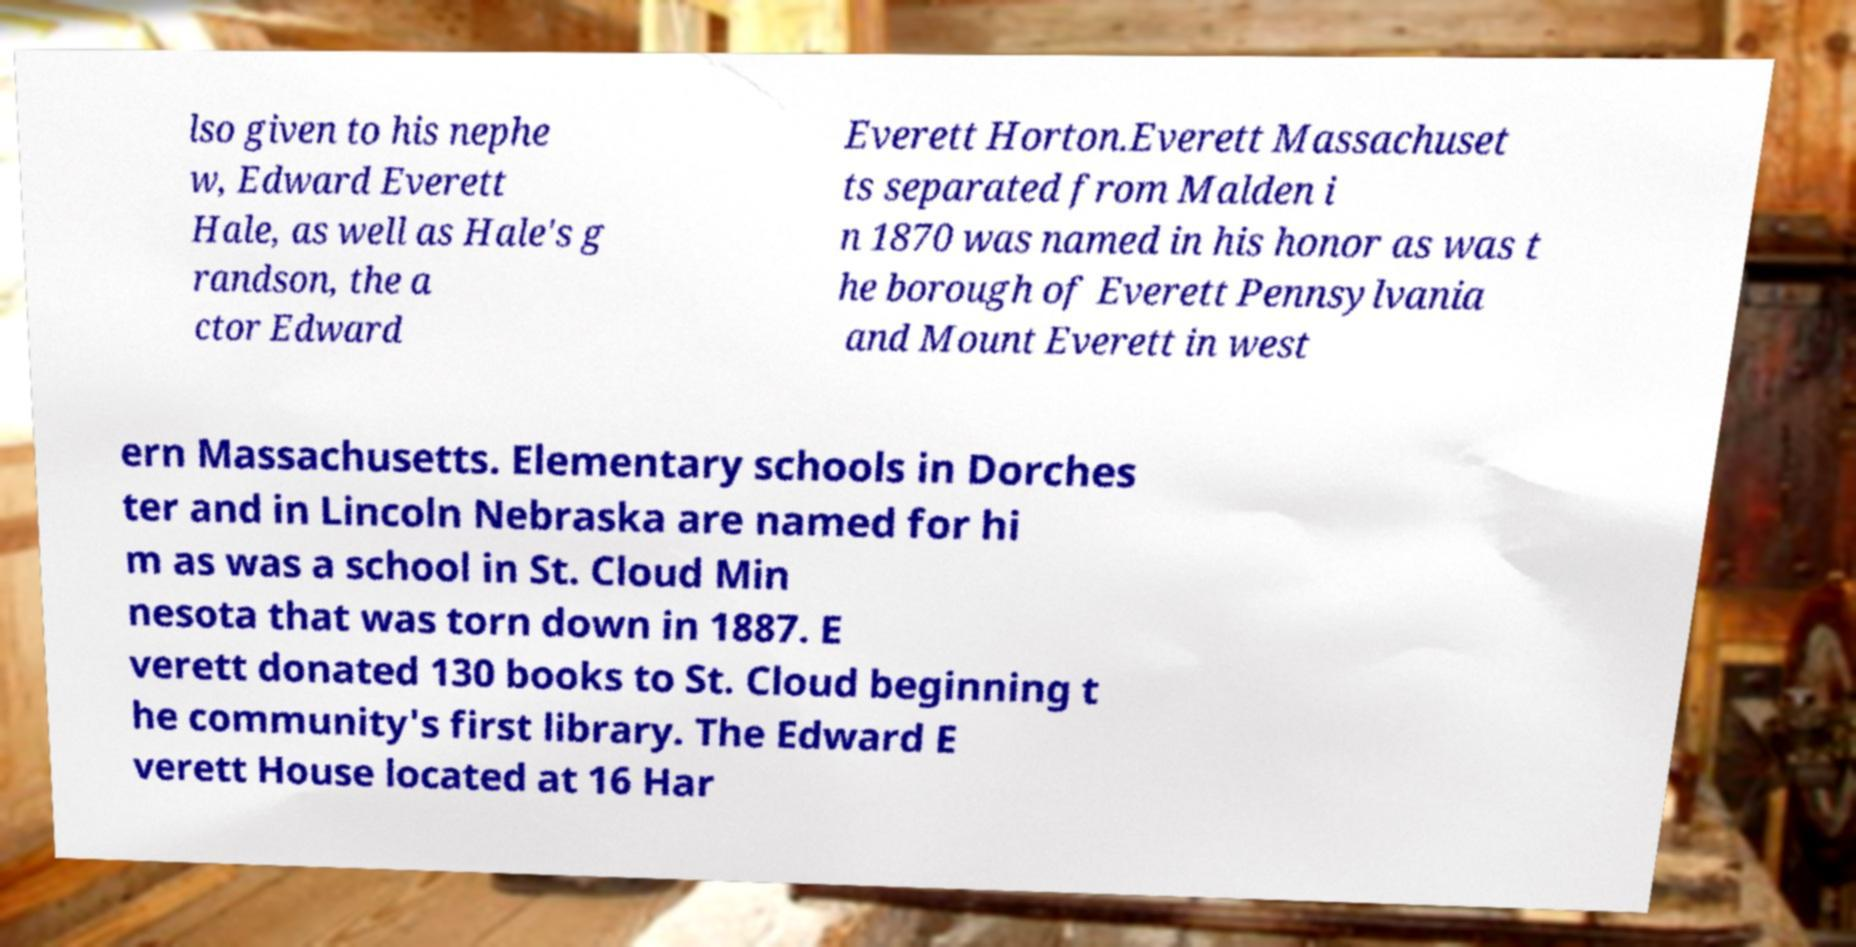I need the written content from this picture converted into text. Can you do that? lso given to his nephe w, Edward Everett Hale, as well as Hale's g randson, the a ctor Edward Everett Horton.Everett Massachuset ts separated from Malden i n 1870 was named in his honor as was t he borough of Everett Pennsylvania and Mount Everett in west ern Massachusetts. Elementary schools in Dorches ter and in Lincoln Nebraska are named for hi m as was a school in St. Cloud Min nesota that was torn down in 1887. E verett donated 130 books to St. Cloud beginning t he community's first library. The Edward E verett House located at 16 Har 